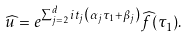<formula> <loc_0><loc_0><loc_500><loc_500>\widehat { u } = e ^ { \sum _ { j = 2 } ^ { d } i t _ { j } \left ( \alpha _ { j } \tau _ { 1 } + \beta _ { j } \right ) } \widehat { f } ( \tau _ { 1 } ) .</formula> 